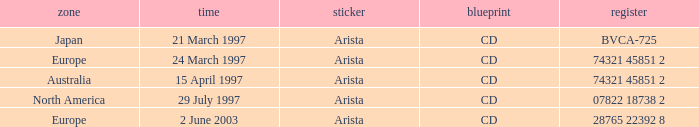Can you give me this table as a dict? {'header': ['zone', 'time', 'sticker', 'blueprint', 'register'], 'rows': [['Japan', '21 March 1997', 'Arista', 'CD', 'BVCA-725'], ['Europe', '24 March 1997', 'Arista', 'CD', '74321 45851 2'], ['Australia', '15 April 1997', 'Arista', 'CD', '74321 45851 2'], ['North America', '29 July 1997', 'Arista', 'CD', '07822 18738 2'], ['Europe', '2 June 2003', 'Arista', 'CD', '28765 22392 8']]} In the region of europe, what date corresponds to the catalog entry with the number 28765 22392 8? 2 June 2003. 